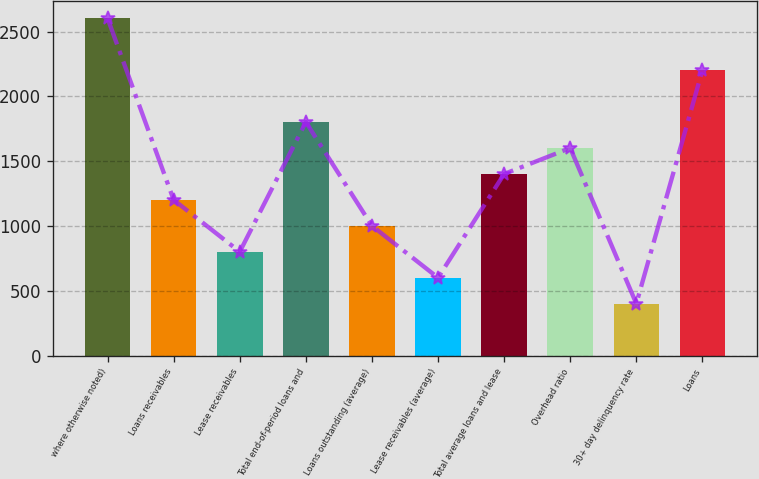Convert chart. <chart><loc_0><loc_0><loc_500><loc_500><bar_chart><fcel>where otherwise noted)<fcel>Loans receivables<fcel>Lease receivables<fcel>Total end-of-period loans and<fcel>Loans outstanding (average)<fcel>Lease receivables (average)<fcel>Total average loans and lease<fcel>Overhead ratio<fcel>30+ day delinquency rate<fcel>Loans<nl><fcel>2602.49<fcel>1201.44<fcel>801.14<fcel>1801.89<fcel>1001.29<fcel>600.99<fcel>1401.59<fcel>1601.74<fcel>400.84<fcel>2202.19<nl></chart> 